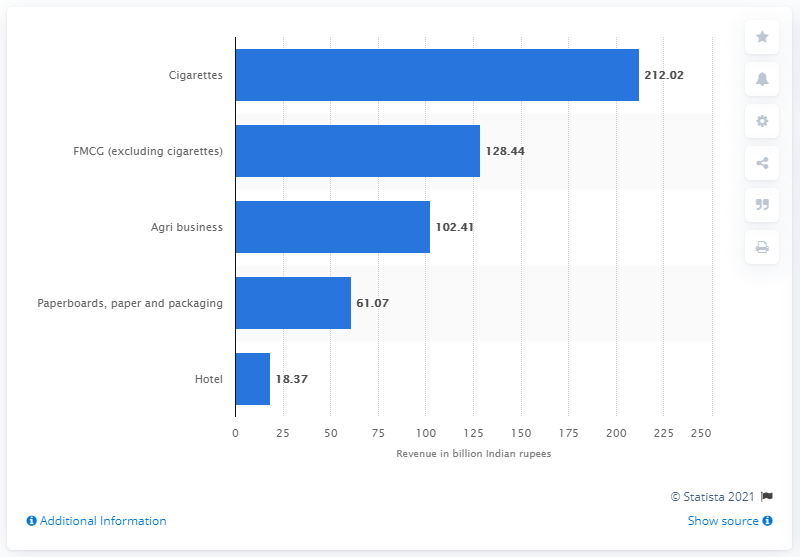List a handful of essential elements in this visual. In the fiscal year 2020, ITC Limited's gross revenue was 212.02 Indian rupees. 